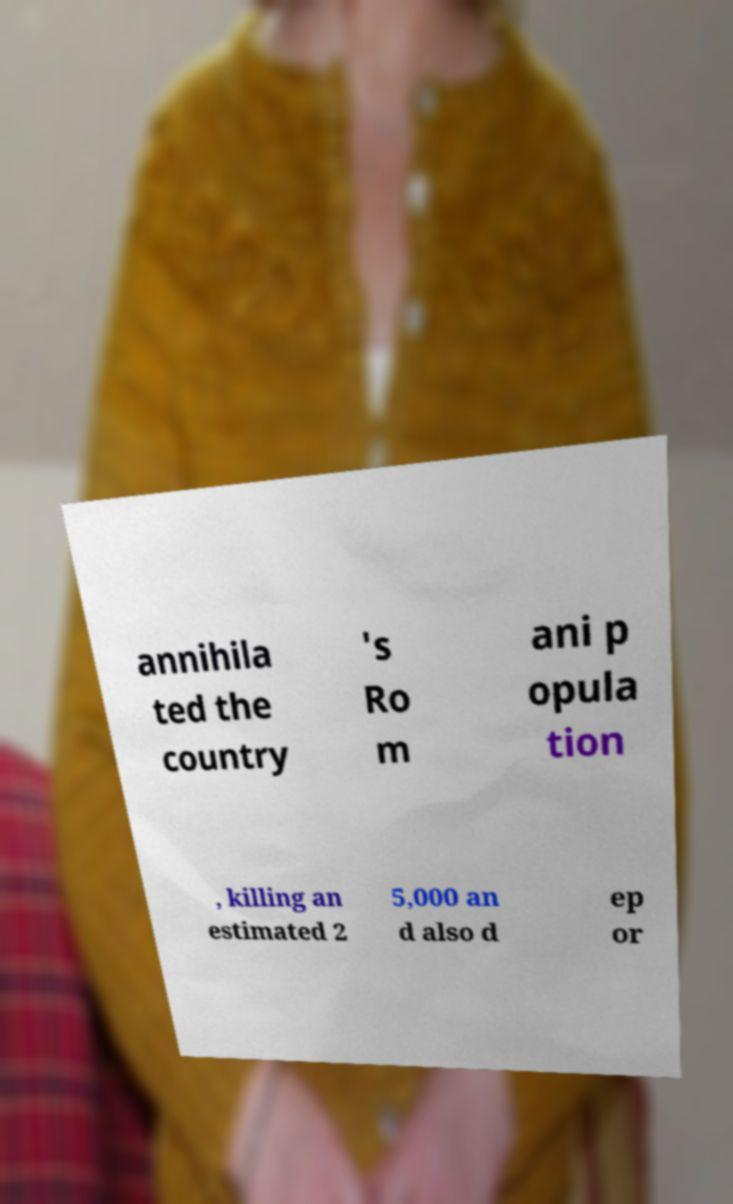What messages or text are displayed in this image? I need them in a readable, typed format. annihila ted the country 's Ro m ani p opula tion , killing an estimated 2 5,000 an d also d ep or 